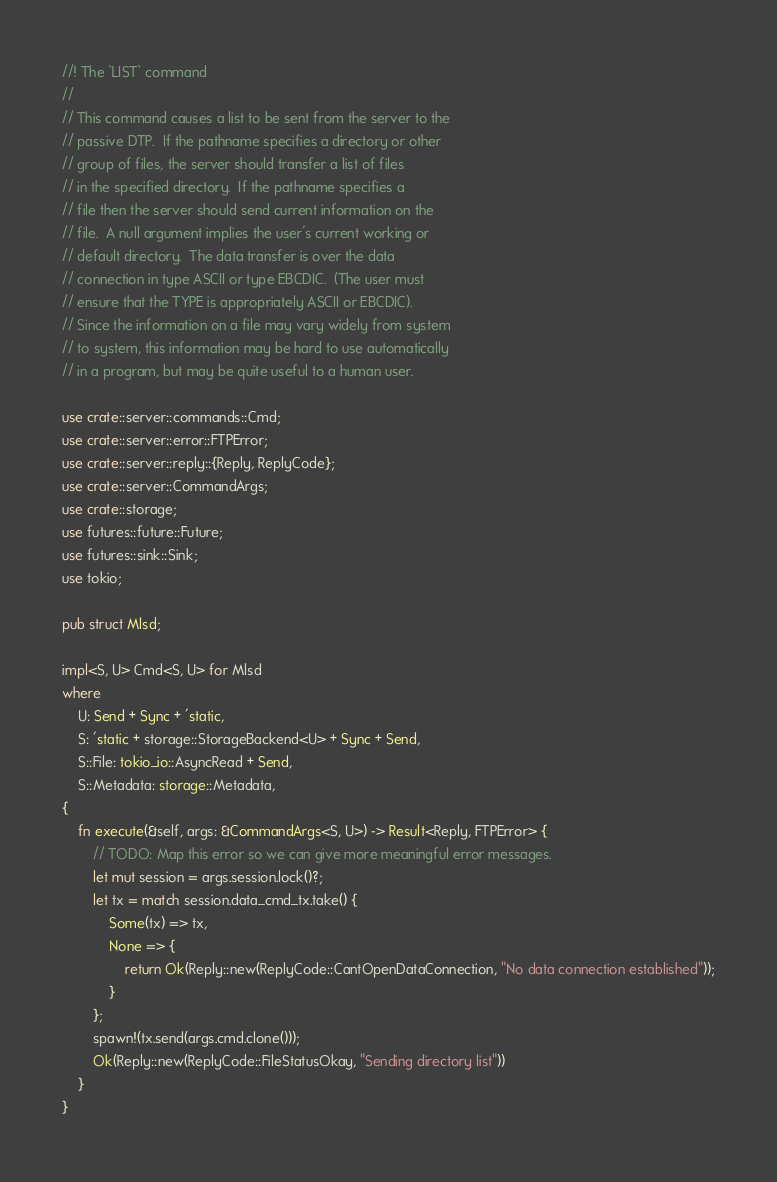Convert code to text. <code><loc_0><loc_0><loc_500><loc_500><_Rust_>//! The `LIST` command
//
// This command causes a list to be sent from the server to the
// passive DTP.  If the pathname specifies a directory or other
// group of files, the server should transfer a list of files
// in the specified directory.  If the pathname specifies a
// file then the server should send current information on the
// file.  A null argument implies the user's current working or
// default directory.  The data transfer is over the data
// connection in type ASCII or type EBCDIC.  (The user must
// ensure that the TYPE is appropriately ASCII or EBCDIC).
// Since the information on a file may vary widely from system
// to system, this information may be hard to use automatically
// in a program, but may be quite useful to a human user.

use crate::server::commands::Cmd;
use crate::server::error::FTPError;
use crate::server::reply::{Reply, ReplyCode};
use crate::server::CommandArgs;
use crate::storage;
use futures::future::Future;
use futures::sink::Sink;
use tokio;

pub struct Mlsd;

impl<S, U> Cmd<S, U> for Mlsd
where
    U: Send + Sync + 'static,
    S: 'static + storage::StorageBackend<U> + Sync + Send,
    S::File: tokio_io::AsyncRead + Send,
    S::Metadata: storage::Metadata,
{
    fn execute(&self, args: &CommandArgs<S, U>) -> Result<Reply, FTPError> {
        // TODO: Map this error so we can give more meaningful error messages.
        let mut session = args.session.lock()?;
        let tx = match session.data_cmd_tx.take() {
            Some(tx) => tx,
            None => {
                return Ok(Reply::new(ReplyCode::CantOpenDataConnection, "No data connection established"));
            }
        };
        spawn!(tx.send(args.cmd.clone()));
        Ok(Reply::new(ReplyCode::FileStatusOkay, "Sending directory list"))
    }
}
</code> 